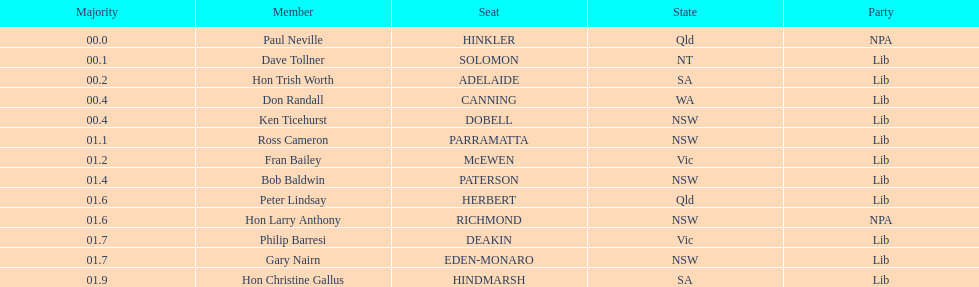What is the difference in majority between hindmarsh and hinkler? 01.9. 